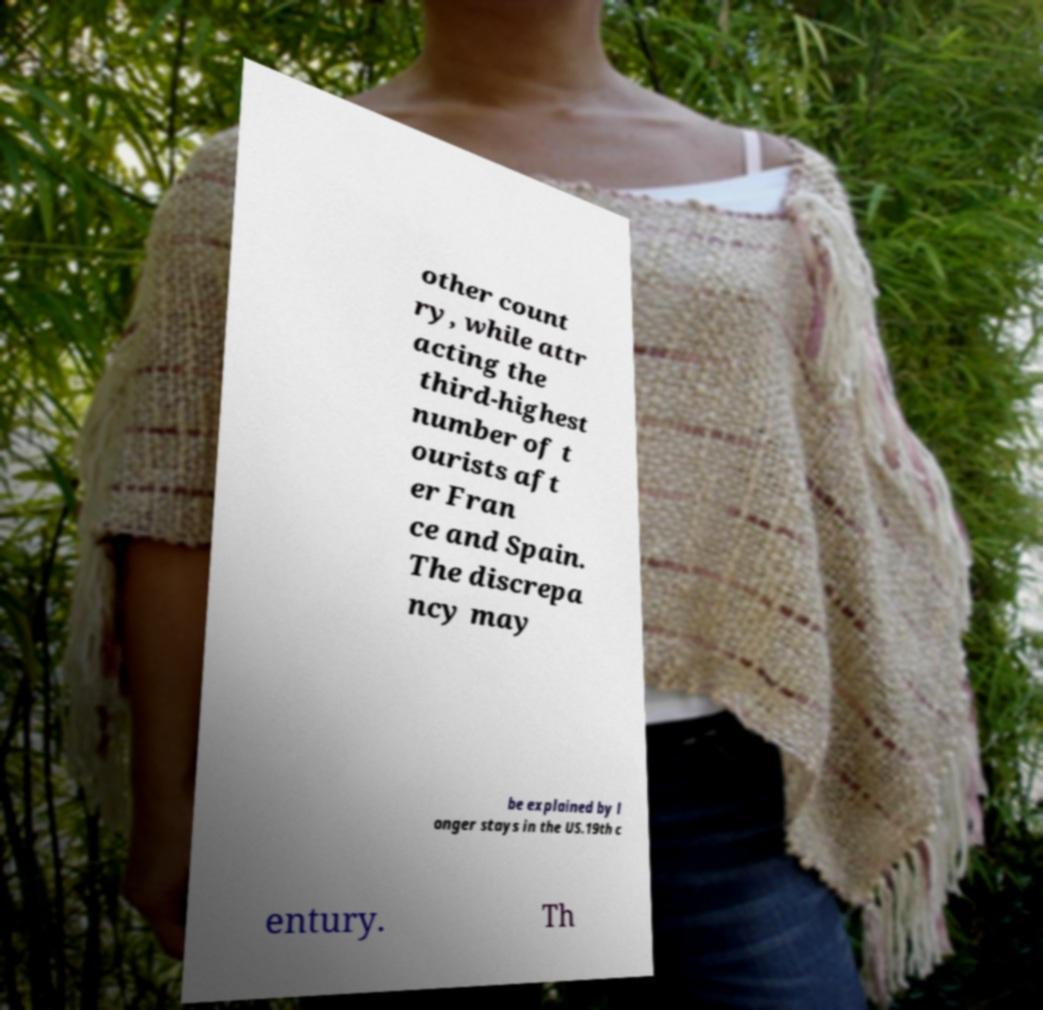For documentation purposes, I need the text within this image transcribed. Could you provide that? other count ry, while attr acting the third-highest number of t ourists aft er Fran ce and Spain. The discrepa ncy may be explained by l onger stays in the US.19th c entury. Th 